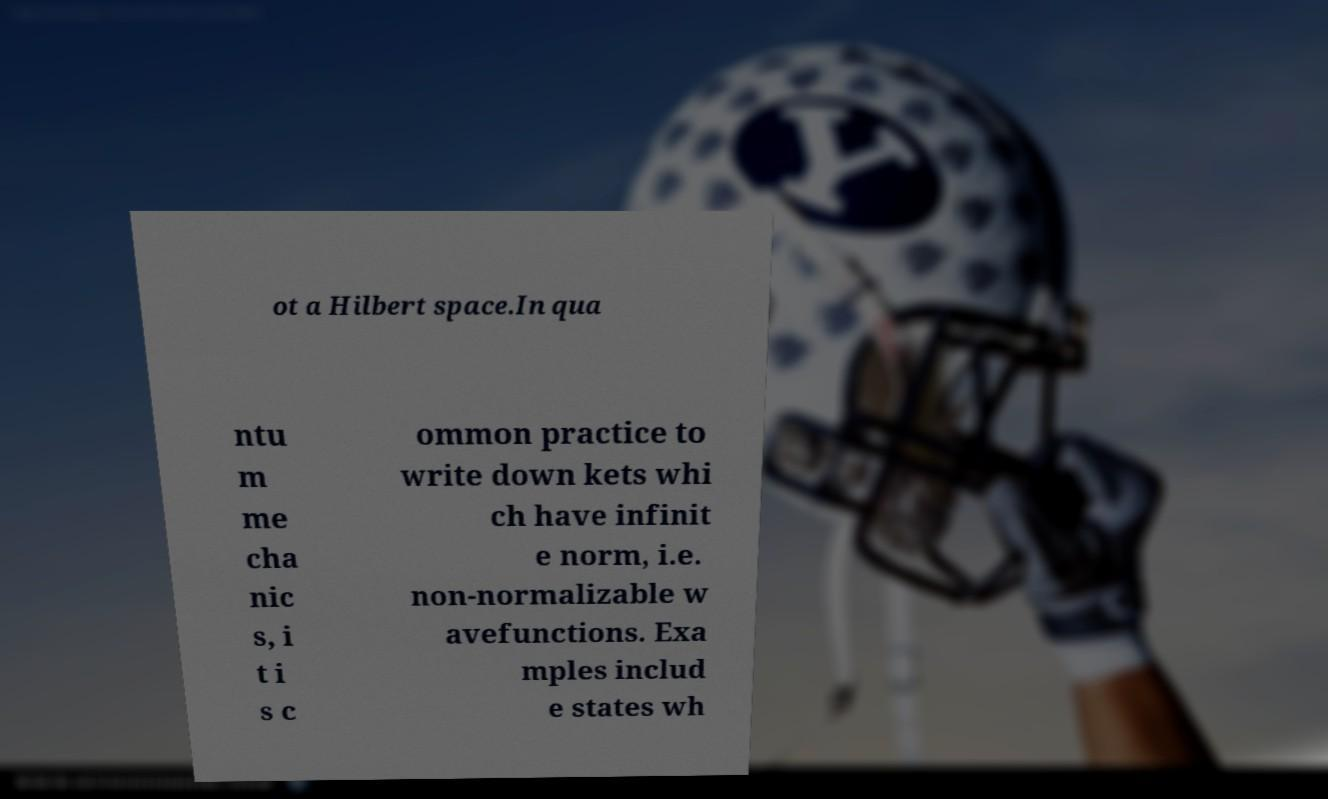What messages or text are displayed in this image? I need them in a readable, typed format. ot a Hilbert space.In qua ntu m me cha nic s, i t i s c ommon practice to write down kets whi ch have infinit e norm, i.e. non-normalizable w avefunctions. Exa mples includ e states wh 